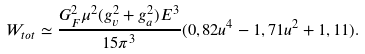Convert formula to latex. <formula><loc_0><loc_0><loc_500><loc_500>W _ { t o t } \simeq \frac { G ^ { 2 } _ { F } \mu ^ { 2 } ( g _ { v } ^ { 2 } + g _ { a } ^ { 2 } ) E ^ { 3 } } { 1 5 \pi ^ { 3 } } ( 0 , 8 2 u ^ { 4 } - 1 , 7 1 u ^ { 2 } + 1 , 1 1 ) .</formula> 